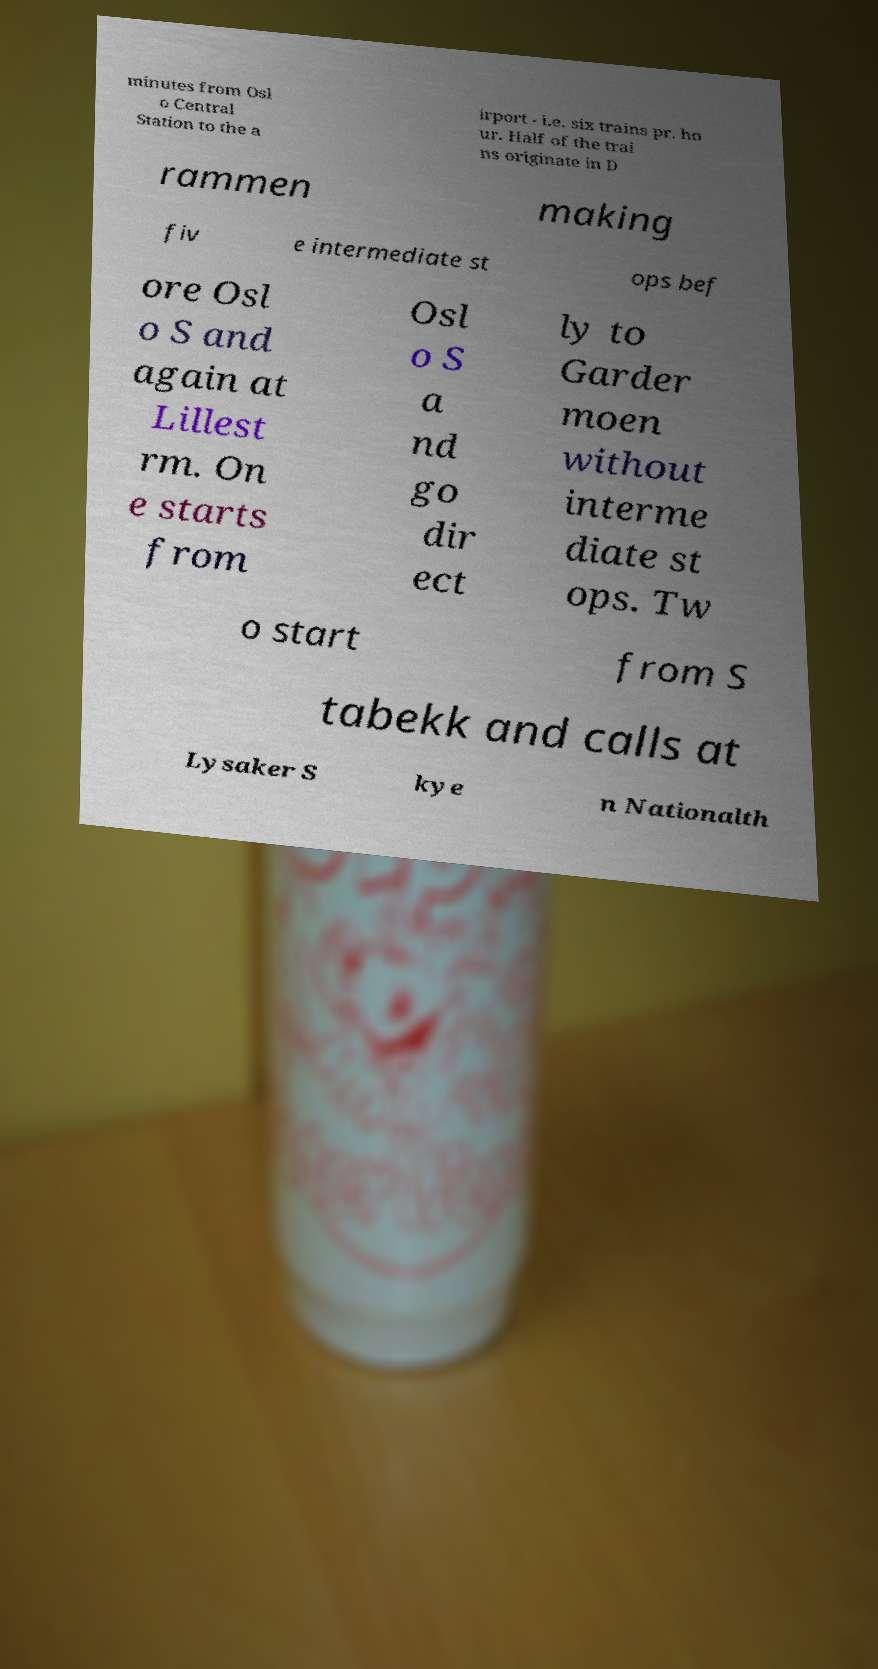There's text embedded in this image that I need extracted. Can you transcribe it verbatim? minutes from Osl o Central Station to the a irport - i.e. six trains pr. ho ur. Half of the trai ns originate in D rammen making fiv e intermediate st ops bef ore Osl o S and again at Lillest rm. On e starts from Osl o S a nd go dir ect ly to Garder moen without interme diate st ops. Tw o start from S tabekk and calls at Lysaker S kye n Nationalth 